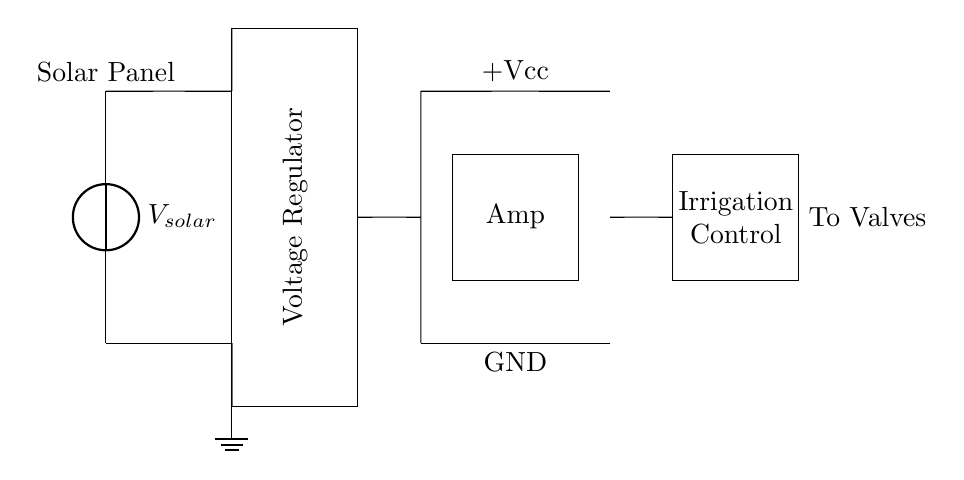What is the main power source for this circuit? The main power source is the solar panel, indicated at the left side of the circuit diagram. This is where the energy is collected to power the subsequent components.
Answer: solar panel What component regulates the output voltage in the circuit? The voltage regulator, shown as a rectangle in the diagram, is responsible for stabilizing the voltage output from the solar panel before supplying it to the amplifier.
Answer: Voltage Regulator What does the amplifier output control in this circuit? The output from the amplifier is used to control irrigation, as indicated by the label near the output section in the diagram. This suggests that the amplified signal is utilized for managing irrigation systems.
Answer: Irrigation Control What is the ground connection in this circuit used for? The ground connection serves as a reference point for the circuit's voltage levels, ensuring stable operation and safety by providing a path for excess current. It is represented as three lines stacked downward in the diagram.
Answer: Ground How many main components are present in this circuit? The circuit features three primary components: the solar panel, voltage regulator, and amplifier. Each component plays a distinct role in the overall function of the irrigation control system.
Answer: Three What is the purpose of the amplifying component in this circuit? The amplifier enhances the signal strength coming from the voltage regulator, allowing it to better control the irrigation valves. This is crucial for making precise adjustments in an off-grid system.
Answer: Enhanced signal What type of irrigation system might this circuit control? This circuit is designed for a greenhouse irrigation system, indicated by its function of managing water flow and ensuring plant care in an off-grid environment.
Answer: Greenhouse irrigation 